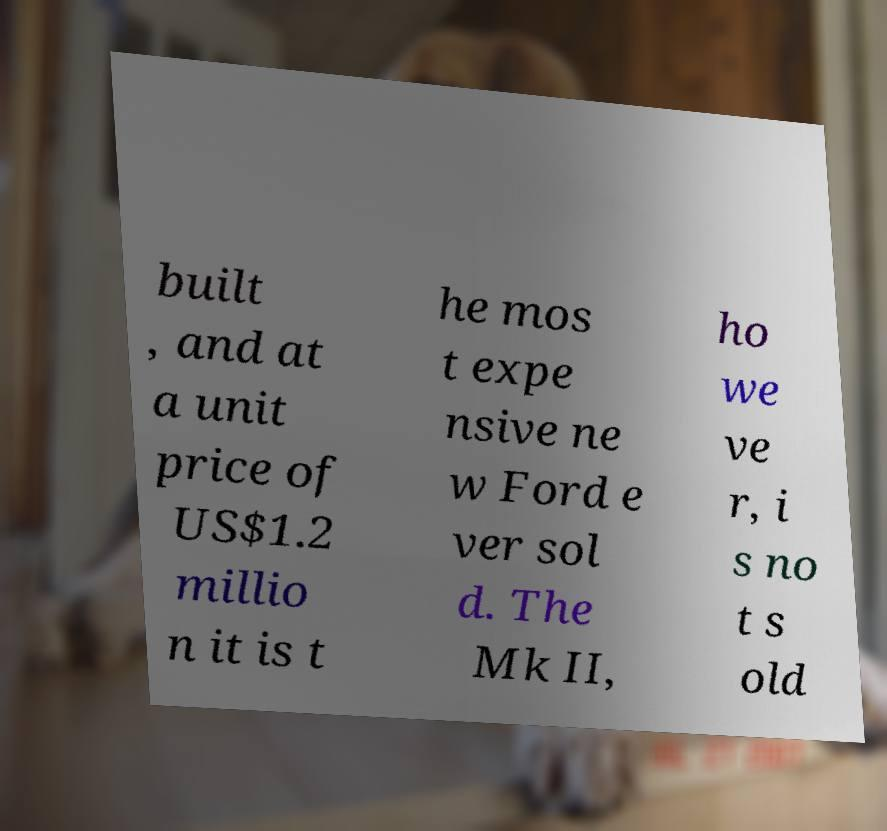Please read and relay the text visible in this image. What does it say? built , and at a unit price of US$1.2 millio n it is t he mos t expe nsive ne w Ford e ver sol d. The Mk II, ho we ve r, i s no t s old 